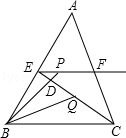First perform reasoning, then finally select the question from the choices in the following format: Answer: xxx.
Question: In triangle ABC, given that BC is 12 units long, E and F are the midpoints of AB and AC respectively, the moving point P is on the radial EF, BP intersects CE at point D, and the bisector of angle CBP intersects CE at point Q. When CQ is 4 units long, what is the value of EP + BP?
Choices:
A: 12.0
B: 18.0
C: 24.0
D: 36.0 As shown in the figure, extend the ray BQ to M on EF. Since E and F are the midpoints of AB and AC respectively, EF is parallel to BC. Therefore, angle M = angle CBM. Since BQ is the bisector of angle CBP, angle PBM = angle CBM. Therefore, angle M = angle PBM. Thus, BP = PM and EP + BP = EP + PM = EM. Since CQ = 4 units, EQ = 2CQ. Due to EF parallel BC, we have triangle MEQ similar to triangle BCQ. Therefore, EM/BC = EQ/CQ = 2. Hence, EM = 2BC = 2 × 12 = 24. Thus, EP + BP = 24. Therefore, the correct answer is C.
Answer:C 